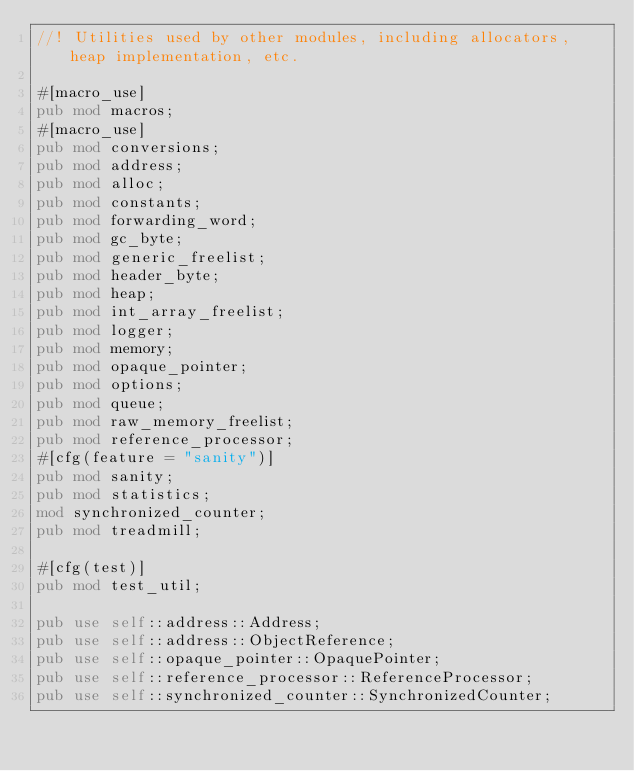<code> <loc_0><loc_0><loc_500><loc_500><_Rust_>//! Utilities used by other modules, including allocators, heap implementation, etc.

#[macro_use]
pub mod macros;
#[macro_use]
pub mod conversions;
pub mod address;
pub mod alloc;
pub mod constants;
pub mod forwarding_word;
pub mod gc_byte;
pub mod generic_freelist;
pub mod header_byte;
pub mod heap;
pub mod int_array_freelist;
pub mod logger;
pub mod memory;
pub mod opaque_pointer;
pub mod options;
pub mod queue;
pub mod raw_memory_freelist;
pub mod reference_processor;
#[cfg(feature = "sanity")]
pub mod sanity;
pub mod statistics;
mod synchronized_counter;
pub mod treadmill;

#[cfg(test)]
pub mod test_util;

pub use self::address::Address;
pub use self::address::ObjectReference;
pub use self::opaque_pointer::OpaquePointer;
pub use self::reference_processor::ReferenceProcessor;
pub use self::synchronized_counter::SynchronizedCounter;
</code> 